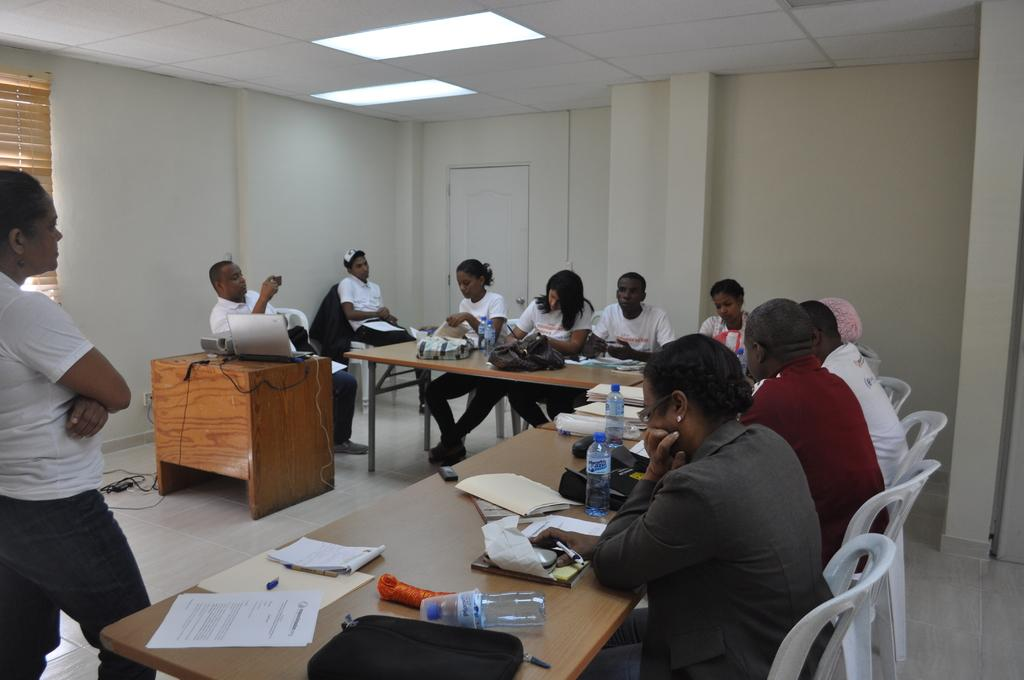What are the people in the image doing? The people in the image are sitting on chairs. What is located in front of the chairs? There is a table in front of the chairs. What can be seen on the table? There are items on the table. What is the woman near the table doing? A woman is standing near the table. How many oranges are on the table in the image? There is no information about oranges in the image, so we cannot determine their presence or quantity. What type of crow is sitting on the woman's shoulder in the image? There is no crow present in the image; only people, chairs, a table, and items are visible. 